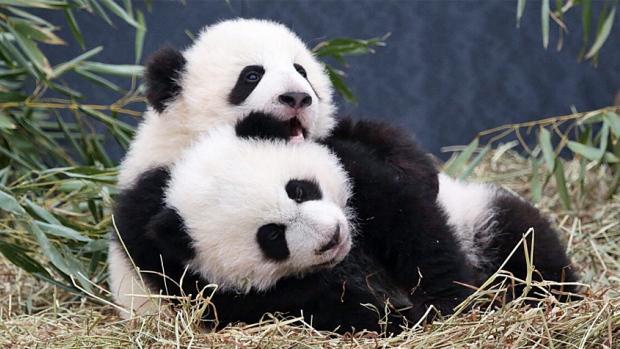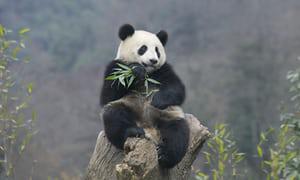The first image is the image on the left, the second image is the image on the right. Given the left and right images, does the statement "In one of the images there are exactly two pandas cuddled together." hold true? Answer yes or no. Yes. The first image is the image on the left, the second image is the image on the right. Given the left and right images, does the statement "Two pandas are on top of each other in one of the images." hold true? Answer yes or no. Yes. 